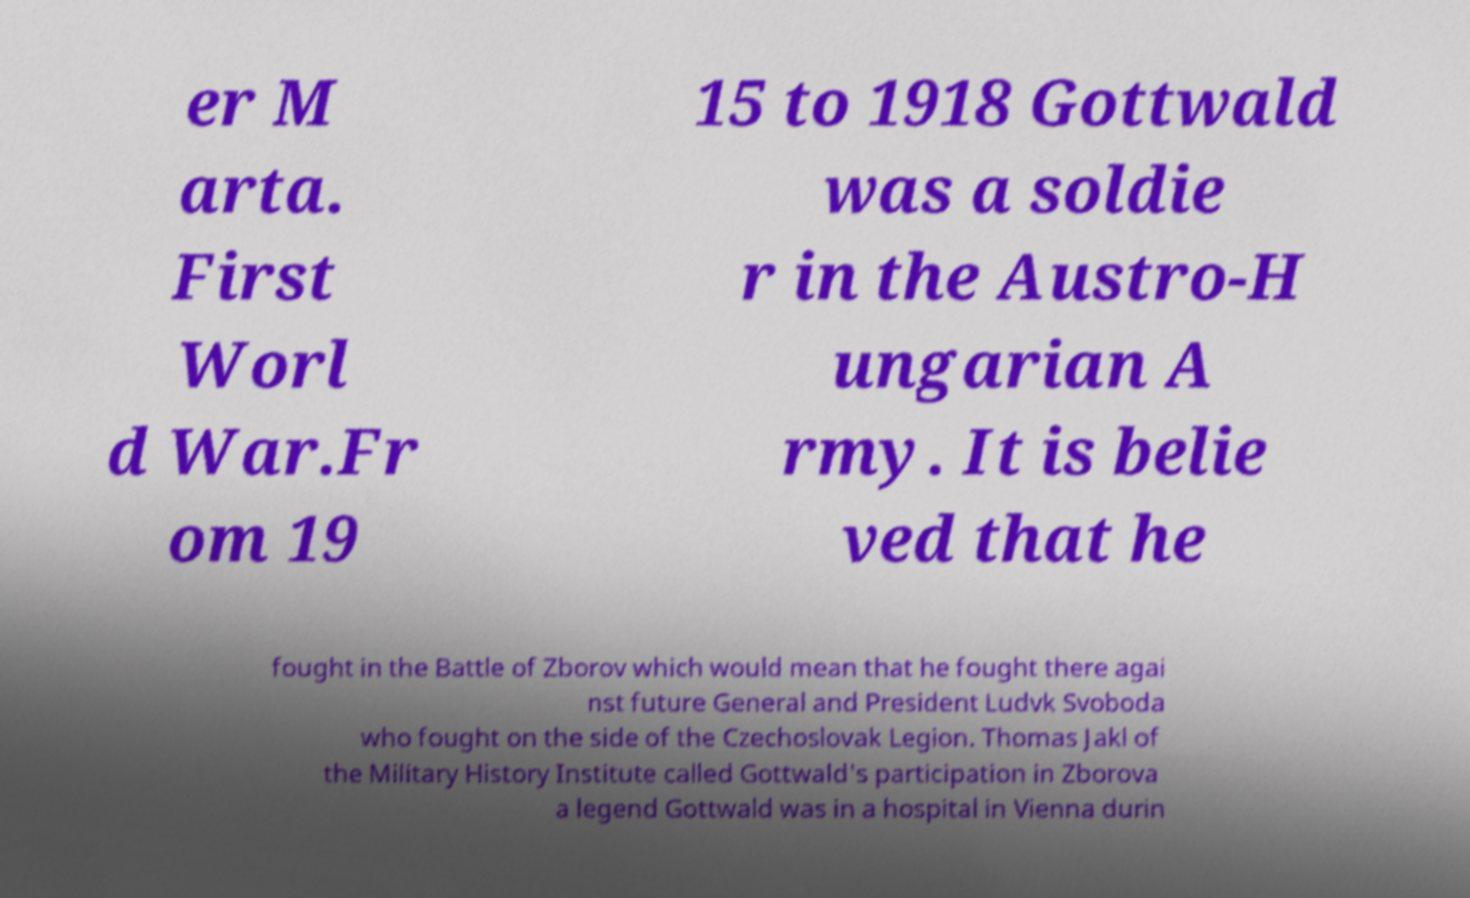For documentation purposes, I need the text within this image transcribed. Could you provide that? er M arta. First Worl d War.Fr om 19 15 to 1918 Gottwald was a soldie r in the Austro-H ungarian A rmy. It is belie ved that he fought in the Battle of Zborov which would mean that he fought there agai nst future General and President Ludvk Svoboda who fought on the side of the Czechoslovak Legion. Thomas Jakl of the Military History Institute called Gottwald's participation in Zborova a legend Gottwald was in a hospital in Vienna durin 